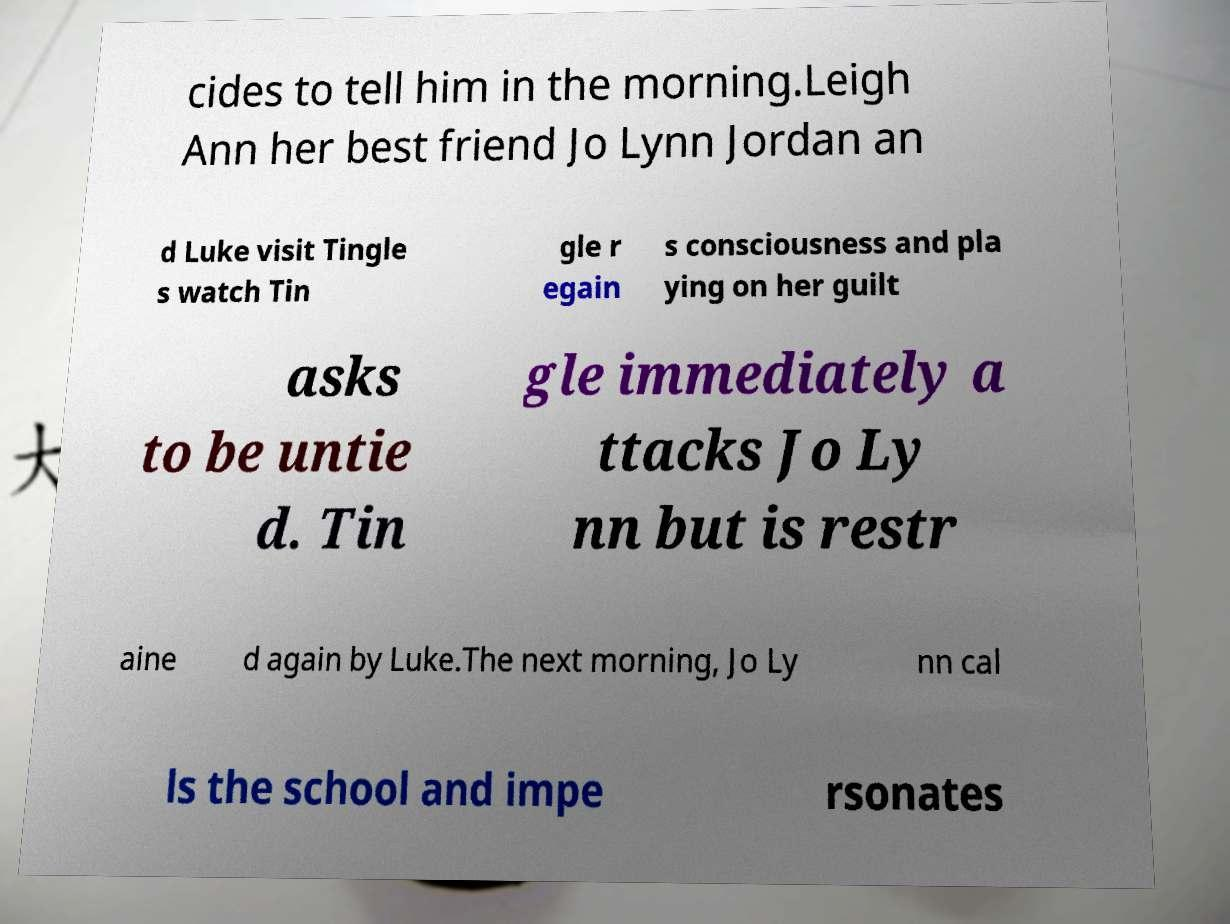There's text embedded in this image that I need extracted. Can you transcribe it verbatim? cides to tell him in the morning.Leigh Ann her best friend Jo Lynn Jordan an d Luke visit Tingle s watch Tin gle r egain s consciousness and pla ying on her guilt asks to be untie d. Tin gle immediately a ttacks Jo Ly nn but is restr aine d again by Luke.The next morning, Jo Ly nn cal ls the school and impe rsonates 